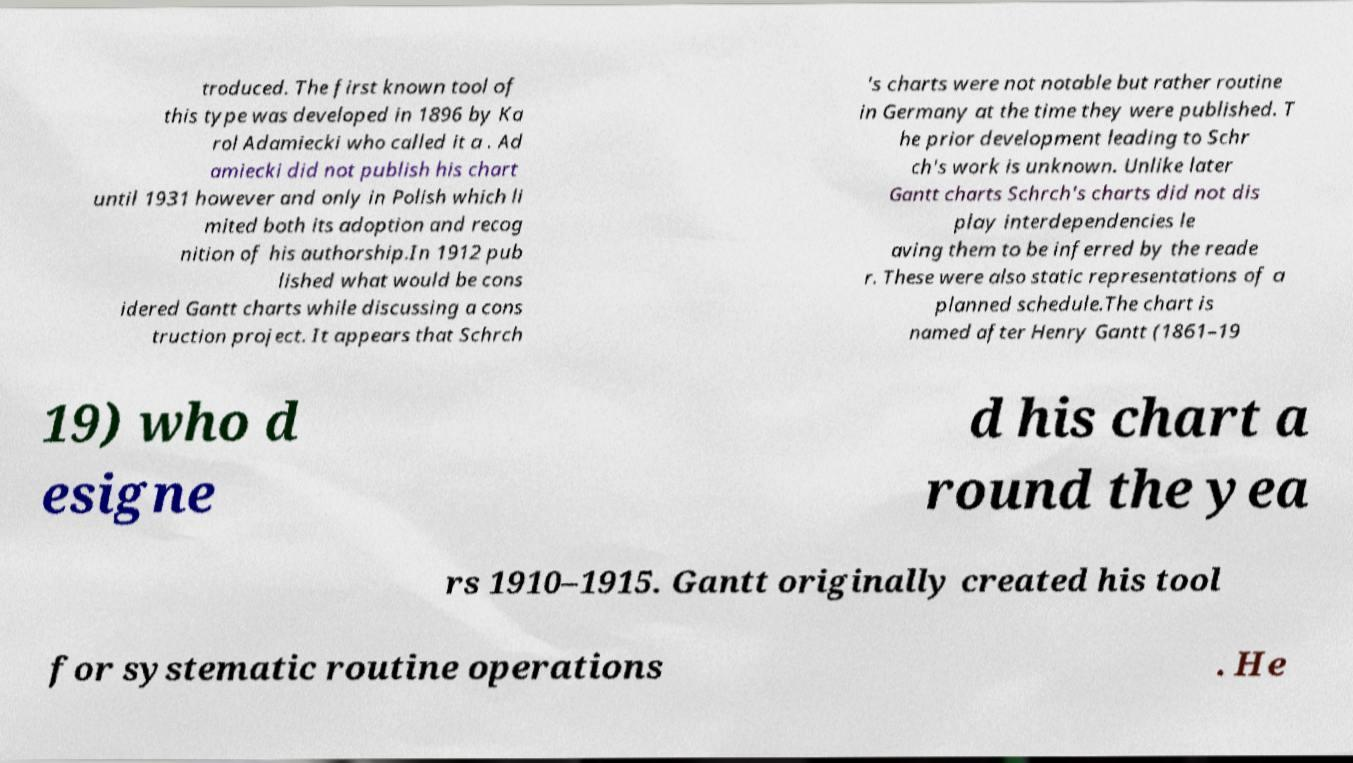Could you assist in decoding the text presented in this image and type it out clearly? troduced. The first known tool of this type was developed in 1896 by Ka rol Adamiecki who called it a . Ad amiecki did not publish his chart until 1931 however and only in Polish which li mited both its adoption and recog nition of his authorship.In 1912 pub lished what would be cons idered Gantt charts while discussing a cons truction project. It appears that Schrch 's charts were not notable but rather routine in Germany at the time they were published. T he prior development leading to Schr ch's work is unknown. Unlike later Gantt charts Schrch's charts did not dis play interdependencies le aving them to be inferred by the reade r. These were also static representations of a planned schedule.The chart is named after Henry Gantt (1861–19 19) who d esigne d his chart a round the yea rs 1910–1915. Gantt originally created his tool for systematic routine operations . He 